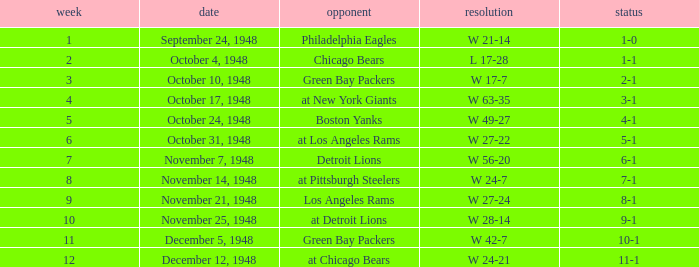Give me the full table as a dictionary. {'header': ['week', 'date', 'opponent', 'resolution', 'status'], 'rows': [['1', 'September 24, 1948', 'Philadelphia Eagles', 'W 21-14', '1-0'], ['2', 'October 4, 1948', 'Chicago Bears', 'L 17-28', '1-1'], ['3', 'October 10, 1948', 'Green Bay Packers', 'W 17-7', '2-1'], ['4', 'October 17, 1948', 'at New York Giants', 'W 63-35', '3-1'], ['5', 'October 24, 1948', 'Boston Yanks', 'W 49-27', '4-1'], ['6', 'October 31, 1948', 'at Los Angeles Rams', 'W 27-22', '5-1'], ['7', 'November 7, 1948', 'Detroit Lions', 'W 56-20', '6-1'], ['8', 'November 14, 1948', 'at Pittsburgh Steelers', 'W 24-7', '7-1'], ['9', 'November 21, 1948', 'Los Angeles Rams', 'W 27-24', '8-1'], ['10', 'November 25, 1948', 'at Detroit Lions', 'W 28-14', '9-1'], ['11', 'December 5, 1948', 'Green Bay Packers', 'W 42-7', '10-1'], ['12', 'December 12, 1948', 'at Chicago Bears', 'W 24-21', '11-1']]} What date was the opponent the Boston Yanks? October 24, 1948. 